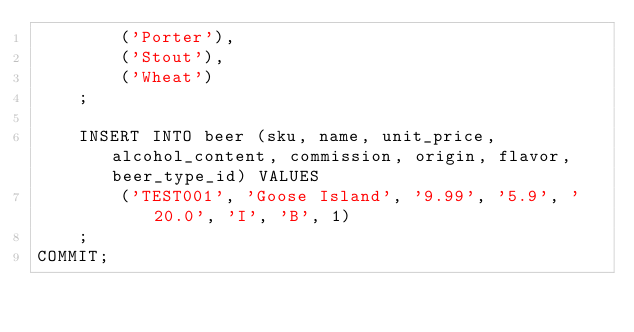Convert code to text. <code><loc_0><loc_0><loc_500><loc_500><_SQL_>        ('Porter'),
        ('Stout'),
        ('Wheat')
    ;

    INSERT INTO beer (sku, name, unit_price, alcohol_content, commission, origin, flavor, beer_type_id) VALUES
        ('TEST001', 'Goose Island', '9.99', '5.9', '20.0', 'I', 'B', 1)
    ;
COMMIT;
</code> 